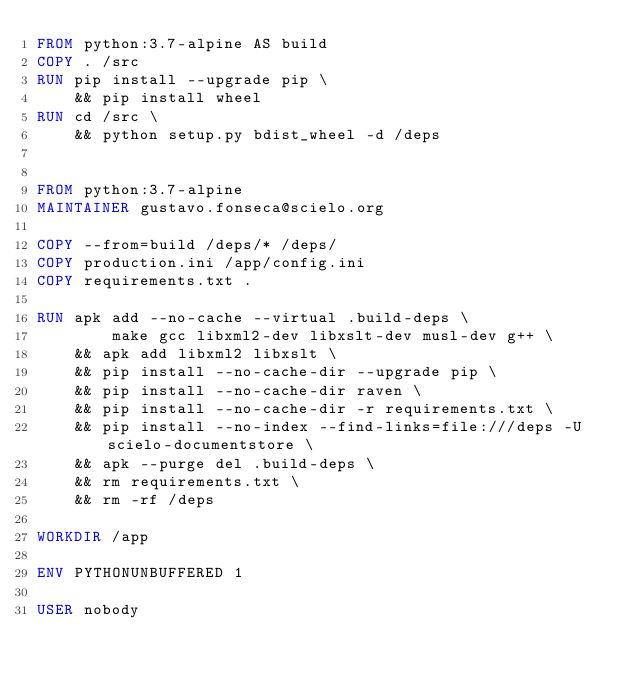<code> <loc_0><loc_0><loc_500><loc_500><_Dockerfile_>FROM python:3.7-alpine AS build
COPY . /src
RUN pip install --upgrade pip \
    && pip install wheel
RUN cd /src \
    && python setup.py bdist_wheel -d /deps


FROM python:3.7-alpine
MAINTAINER gustavo.fonseca@scielo.org

COPY --from=build /deps/* /deps/
COPY production.ini /app/config.ini
COPY requirements.txt .

RUN apk add --no-cache --virtual .build-deps \
        make gcc libxml2-dev libxslt-dev musl-dev g++ \
    && apk add libxml2 libxslt \
    && pip install --no-cache-dir --upgrade pip \
    && pip install --no-cache-dir raven \
    && pip install --no-cache-dir -r requirements.txt \
    && pip install --no-index --find-links=file:///deps -U scielo-documentstore \
    && apk --purge del .build-deps \
    && rm requirements.txt \
    && rm -rf /deps

WORKDIR /app

ENV PYTHONUNBUFFERED 1

USER nobody

</code> 